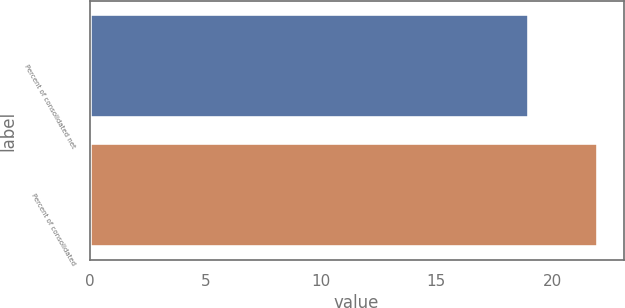<chart> <loc_0><loc_0><loc_500><loc_500><bar_chart><fcel>Percent of consolidated net<fcel>Percent of consolidated<nl><fcel>19<fcel>22<nl></chart> 